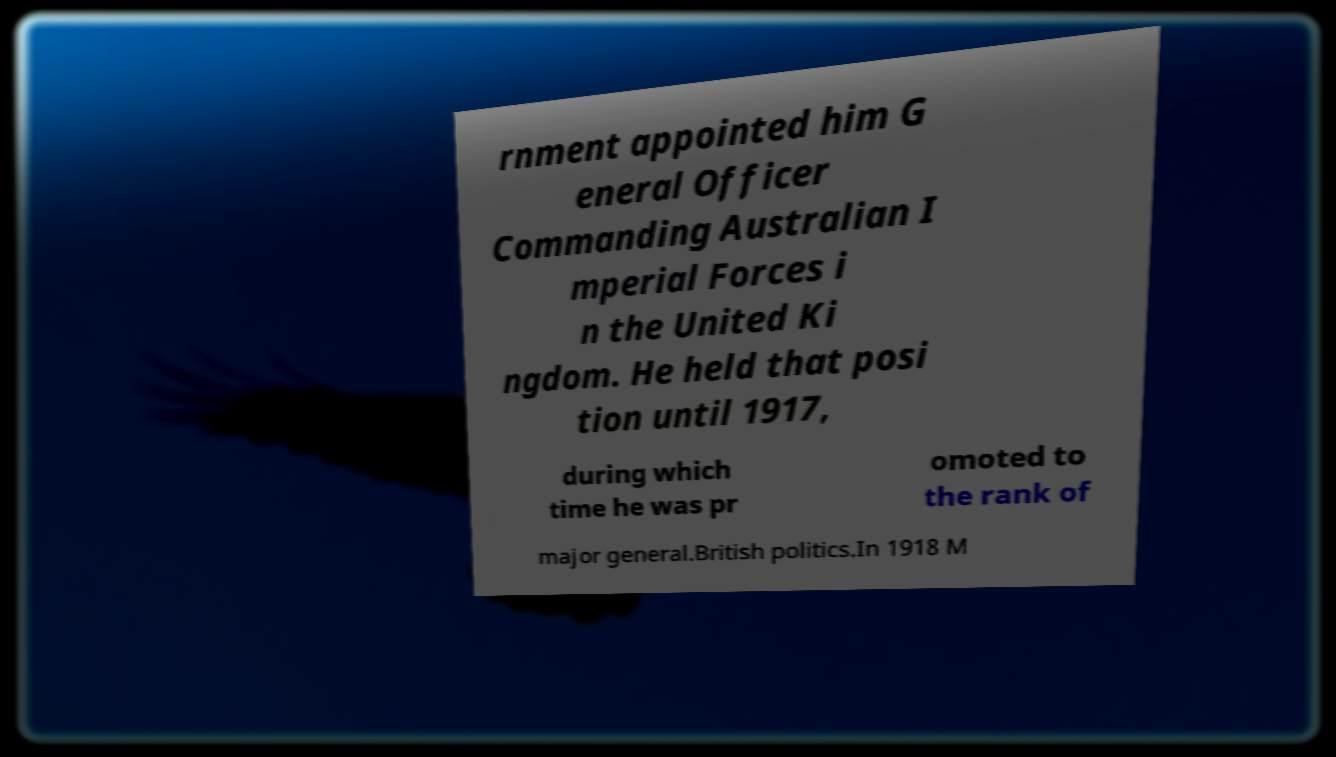Could you extract and type out the text from this image? rnment appointed him G eneral Officer Commanding Australian I mperial Forces i n the United Ki ngdom. He held that posi tion until 1917, during which time he was pr omoted to the rank of major general.British politics.In 1918 M 